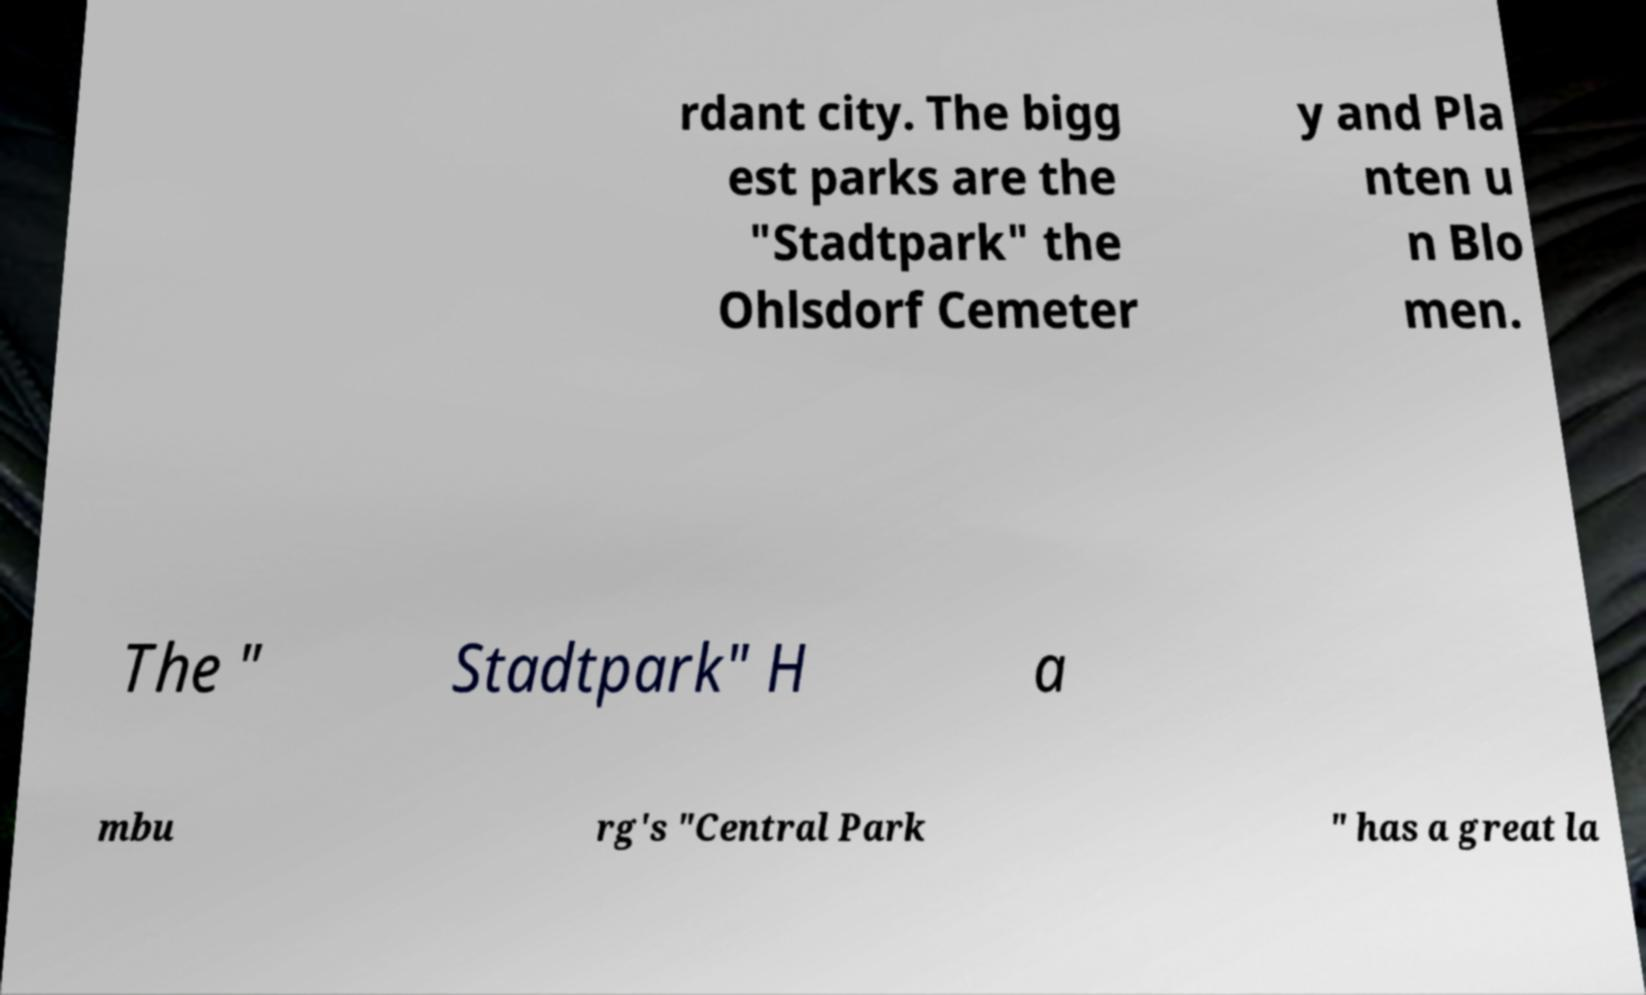There's text embedded in this image that I need extracted. Can you transcribe it verbatim? rdant city. The bigg est parks are the "Stadtpark" the Ohlsdorf Cemeter y and Pla nten u n Blo men. The " Stadtpark" H a mbu rg's "Central Park " has a great la 